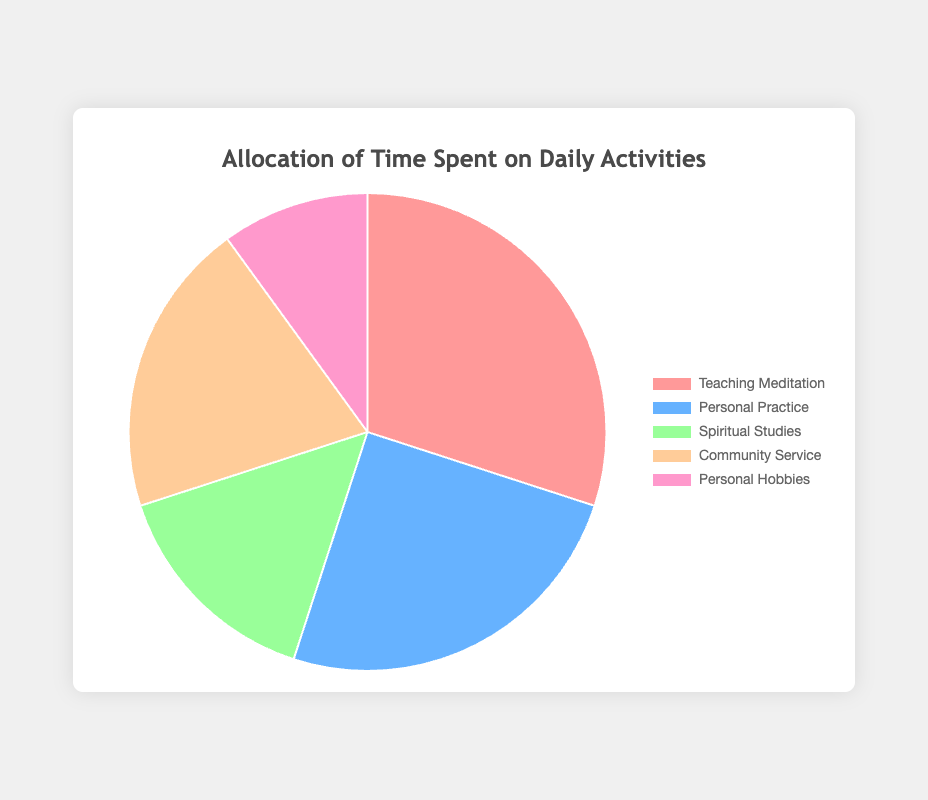Which activity takes up the most time in a day? The activity with the largest percentage in the pie chart represents the one taking the most time. Here, 'Teaching Meditation' is shown to take up 30%, which is the highest portion.
Answer: Teaching Meditation Which two activities together make up 45% of a day's time? Adding up the percentages of the activities, we find that 'Personal Practice' (25%) and 'Spiritual Studies' (15%) together make up 40%, while 'Personal Practice' (25%) and 'Community Service' (20%) make up 45%.
Answer: Personal Practice and Community Service What is the difference in time allocation between 'Teaching Meditation' and 'Personal Hobbies'? The percentage for 'Teaching Meditation' is 30% and for 'Personal Hobbies' it is 10%. The difference is obtained by subtracting the smaller percentage from the larger one: 30% - 10% = 20%.
Answer: 20% Which activity takes up the least amount of time? The activity with the smallest percentage in the pie chart takes the least amount of time. 'Personal Hobbies' represents 10%, which is the smallest portion.
Answer: Personal Hobbies What is the total percentage of time allocated to 'Personal Practice', 'Spiritual Studies', and 'Community Service' combined? Adding the percentages for 'Personal Practice' (25%), 'Spiritual Studies' (15%), and 'Community Service' (20%) gives: 25% + 15% + 20% = 60%.
Answer: 60% Is the time spent on 'Community Service' greater than the sum of 'Spiritual Studies' and 'Personal Hobbies' combined? The percentage for 'Community Service' is 20%. The sum of 'Spiritual Studies' (15%) and 'Personal Hobbies' (10%) is: 15% + 10% = 25%. Since 20% is less than 25%, the time spent on 'Community Service' is not greater.
Answer: No Which activity has a larger time allocation, 'Personal Practice' or 'Community Service'? The percentage for 'Personal Practice' is 25%, and for 'Community Service' it is 20%. Since 25% is larger than 20%, 'Personal Practice' has a larger time allocation.
Answer: Personal Practice What is the percentage difference between the highest and lowest allocated activities? The highest allocated activity, 'Teaching Meditation', is 30%, and the lowest, 'Personal Hobbies', is 10%. The difference is 30% - 10% = 20%.
Answer: 20% What percentage of time is spent on activities related to teaching ('Teaching Meditation' and 'Community Service')? Adding the percentages for 'Teaching Meditation' (30%) and 'Community Service' (20%) gives: 30% + 20% = 50%.
Answer: 50% Which two activities have the closest percentages in time allocation? The closest time allocations can be found by comparing the differences: 'Teaching Meditation' (30%) and 'Personal Practice' (25%) have a difference of 5%. 'Personal Practice' (25%) and 'Community Service' (20%) also have a difference of 5%, but checking further, 'Spiritual Studies' (15%) and 'Personal Hobbies' (10%) have a difference of 5%. Hence, multiple pairs are close.
Answer: Personal Practice and Community Service 